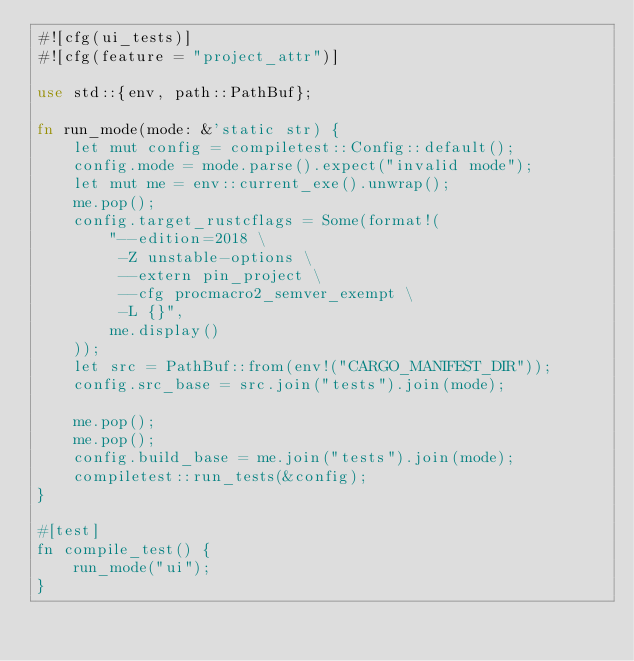<code> <loc_0><loc_0><loc_500><loc_500><_Rust_>#![cfg(ui_tests)]
#![cfg(feature = "project_attr")]

use std::{env, path::PathBuf};

fn run_mode(mode: &'static str) {
    let mut config = compiletest::Config::default();
    config.mode = mode.parse().expect("invalid mode");
    let mut me = env::current_exe().unwrap();
    me.pop();
    config.target_rustcflags = Some(format!(
        "--edition=2018 \
         -Z unstable-options \
         --extern pin_project \
         --cfg procmacro2_semver_exempt \
         -L {}",
        me.display()
    ));
    let src = PathBuf::from(env!("CARGO_MANIFEST_DIR"));
    config.src_base = src.join("tests").join(mode);

    me.pop();
    me.pop();
    config.build_base = me.join("tests").join(mode);
    compiletest::run_tests(&config);
}

#[test]
fn compile_test() {
    run_mode("ui");
}
</code> 